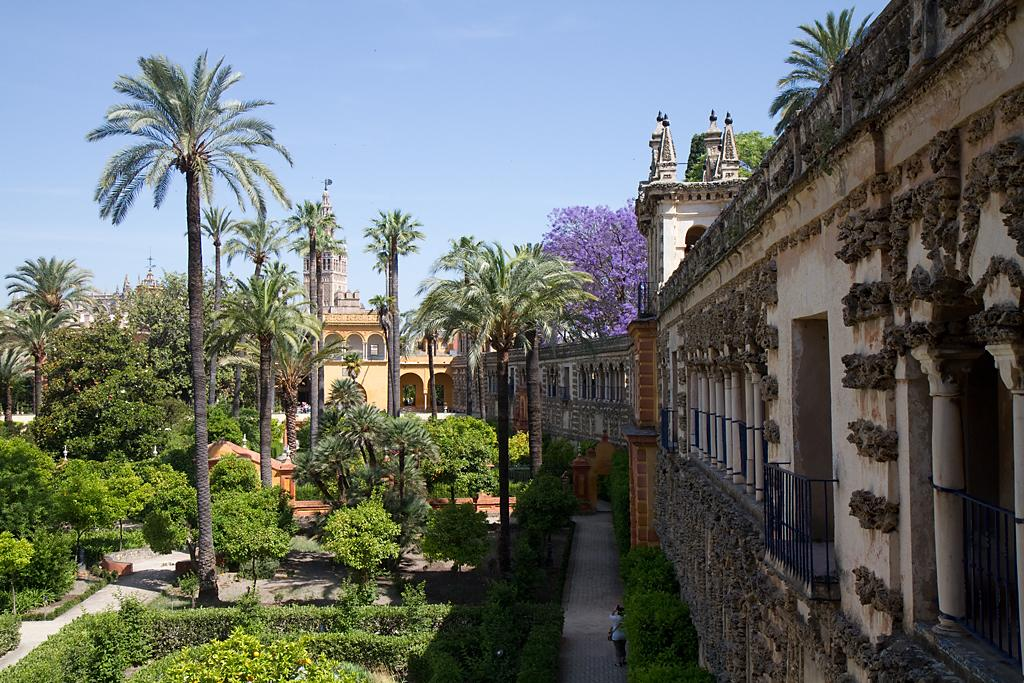What type of structures can be seen in the image? There are buildings in the image. What natural elements are present in the image? There are trees, plants, and grass in the image. What objects are used for cooking in the image? There are grills in the image. Is there a person present in the image? Yes, there is a person in the image. What can be seen in the background of the image? The sky is visible in the background of the image. What type of bells can be heard ringing in the image? There are no bells present in the image, and therefore no sound can be heard. What type of grain is being harvested in the image? There is no grain being harvested in the image; it features buildings, trees, plants, grass, grills, and a person. 